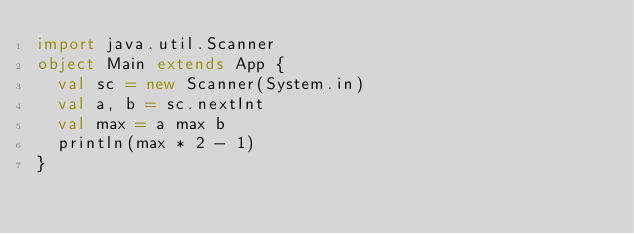Convert code to text. <code><loc_0><loc_0><loc_500><loc_500><_Scala_>import java.util.Scanner
object Main extends App {
  val sc = new Scanner(System.in)
  val a, b = sc.nextInt
  val max = a max b
  println(max * 2 - 1)
}</code> 